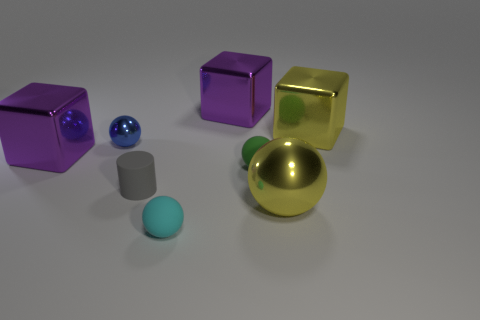Subtract 1 spheres. How many spheres are left? 3 Add 2 small green blocks. How many objects exist? 10 Subtract all cylinders. How many objects are left? 7 Add 8 small gray rubber cylinders. How many small gray rubber cylinders exist? 9 Subtract 0 cyan cylinders. How many objects are left? 8 Subtract all small gray cylinders. Subtract all small green matte spheres. How many objects are left? 6 Add 8 small blue objects. How many small blue objects are left? 9 